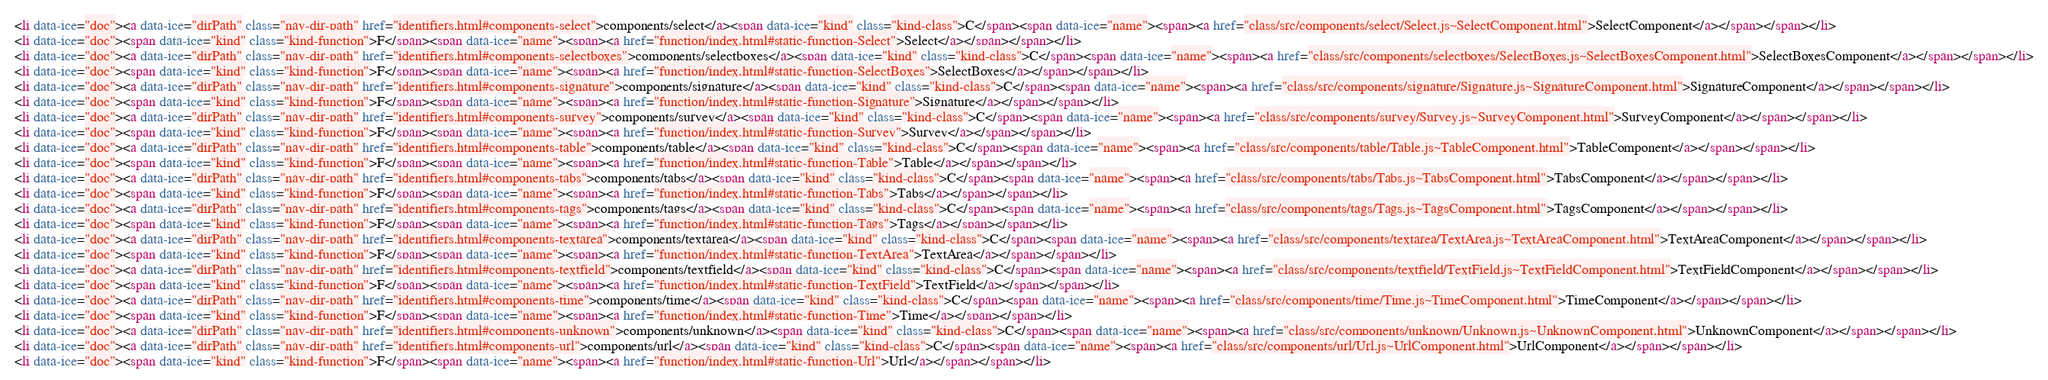Convert code to text. <code><loc_0><loc_0><loc_500><loc_500><_HTML_><li data-ice="doc"><a data-ice="dirPath" class="nav-dir-path" href="identifiers.html#components-select">components/select</a><span data-ice="kind" class="kind-class">C</span><span data-ice="name"><span><a href="class/src/components/select/Select.js~SelectComponent.html">SelectComponent</a></span></span></li>
<li data-ice="doc"><span data-ice="kind" class="kind-function">F</span><span data-ice="name"><span><a href="function/index.html#static-function-Select">Select</a></span></span></li>
<li data-ice="doc"><a data-ice="dirPath" class="nav-dir-path" href="identifiers.html#components-selectboxes">components/selectboxes</a><span data-ice="kind" class="kind-class">C</span><span data-ice="name"><span><a href="class/src/components/selectboxes/SelectBoxes.js~SelectBoxesComponent.html">SelectBoxesComponent</a></span></span></li>
<li data-ice="doc"><span data-ice="kind" class="kind-function">F</span><span data-ice="name"><span><a href="function/index.html#static-function-SelectBoxes">SelectBoxes</a></span></span></li>
<li data-ice="doc"><a data-ice="dirPath" class="nav-dir-path" href="identifiers.html#components-signature">components/signature</a><span data-ice="kind" class="kind-class">C</span><span data-ice="name"><span><a href="class/src/components/signature/Signature.js~SignatureComponent.html">SignatureComponent</a></span></span></li>
<li data-ice="doc"><span data-ice="kind" class="kind-function">F</span><span data-ice="name"><span><a href="function/index.html#static-function-Signature">Signature</a></span></span></li>
<li data-ice="doc"><a data-ice="dirPath" class="nav-dir-path" href="identifiers.html#components-survey">components/survey</a><span data-ice="kind" class="kind-class">C</span><span data-ice="name"><span><a href="class/src/components/survey/Survey.js~SurveyComponent.html">SurveyComponent</a></span></span></li>
<li data-ice="doc"><span data-ice="kind" class="kind-function">F</span><span data-ice="name"><span><a href="function/index.html#static-function-Survey">Survey</a></span></span></li>
<li data-ice="doc"><a data-ice="dirPath" class="nav-dir-path" href="identifiers.html#components-table">components/table</a><span data-ice="kind" class="kind-class">C</span><span data-ice="name"><span><a href="class/src/components/table/Table.js~TableComponent.html">TableComponent</a></span></span></li>
<li data-ice="doc"><span data-ice="kind" class="kind-function">F</span><span data-ice="name"><span><a href="function/index.html#static-function-Table">Table</a></span></span></li>
<li data-ice="doc"><a data-ice="dirPath" class="nav-dir-path" href="identifiers.html#components-tabs">components/tabs</a><span data-ice="kind" class="kind-class">C</span><span data-ice="name"><span><a href="class/src/components/tabs/Tabs.js~TabsComponent.html">TabsComponent</a></span></span></li>
<li data-ice="doc"><span data-ice="kind" class="kind-function">F</span><span data-ice="name"><span><a href="function/index.html#static-function-Tabs">Tabs</a></span></span></li>
<li data-ice="doc"><a data-ice="dirPath" class="nav-dir-path" href="identifiers.html#components-tags">components/tags</a><span data-ice="kind" class="kind-class">C</span><span data-ice="name"><span><a href="class/src/components/tags/Tags.js~TagsComponent.html">TagsComponent</a></span></span></li>
<li data-ice="doc"><span data-ice="kind" class="kind-function">F</span><span data-ice="name"><span><a href="function/index.html#static-function-Tags">Tags</a></span></span></li>
<li data-ice="doc"><a data-ice="dirPath" class="nav-dir-path" href="identifiers.html#components-textarea">components/textarea</a><span data-ice="kind" class="kind-class">C</span><span data-ice="name"><span><a href="class/src/components/textarea/TextArea.js~TextAreaComponent.html">TextAreaComponent</a></span></span></li>
<li data-ice="doc"><span data-ice="kind" class="kind-function">F</span><span data-ice="name"><span><a href="function/index.html#static-function-TextArea">TextArea</a></span></span></li>
<li data-ice="doc"><a data-ice="dirPath" class="nav-dir-path" href="identifiers.html#components-textfield">components/textfield</a><span data-ice="kind" class="kind-class">C</span><span data-ice="name"><span><a href="class/src/components/textfield/TextField.js~TextFieldComponent.html">TextFieldComponent</a></span></span></li>
<li data-ice="doc"><span data-ice="kind" class="kind-function">F</span><span data-ice="name"><span><a href="function/index.html#static-function-TextField">TextField</a></span></span></li>
<li data-ice="doc"><a data-ice="dirPath" class="nav-dir-path" href="identifiers.html#components-time">components/time</a><span data-ice="kind" class="kind-class">C</span><span data-ice="name"><span><a href="class/src/components/time/Time.js~TimeComponent.html">TimeComponent</a></span></span></li>
<li data-ice="doc"><span data-ice="kind" class="kind-function">F</span><span data-ice="name"><span><a href="function/index.html#static-function-Time">Time</a></span></span></li>
<li data-ice="doc"><a data-ice="dirPath" class="nav-dir-path" href="identifiers.html#components-unknown">components/unknown</a><span data-ice="kind" class="kind-class">C</span><span data-ice="name"><span><a href="class/src/components/unknown/Unknown.js~UnknownComponent.html">UnknownComponent</a></span></span></li>
<li data-ice="doc"><a data-ice="dirPath" class="nav-dir-path" href="identifiers.html#components-url">components/url</a><span data-ice="kind" class="kind-class">C</span><span data-ice="name"><span><a href="class/src/components/url/Url.js~UrlComponent.html">UrlComponent</a></span></span></li>
<li data-ice="doc"><span data-ice="kind" class="kind-function">F</span><span data-ice="name"><span><a href="function/index.html#static-function-Url">Url</a></span></span></li></code> 